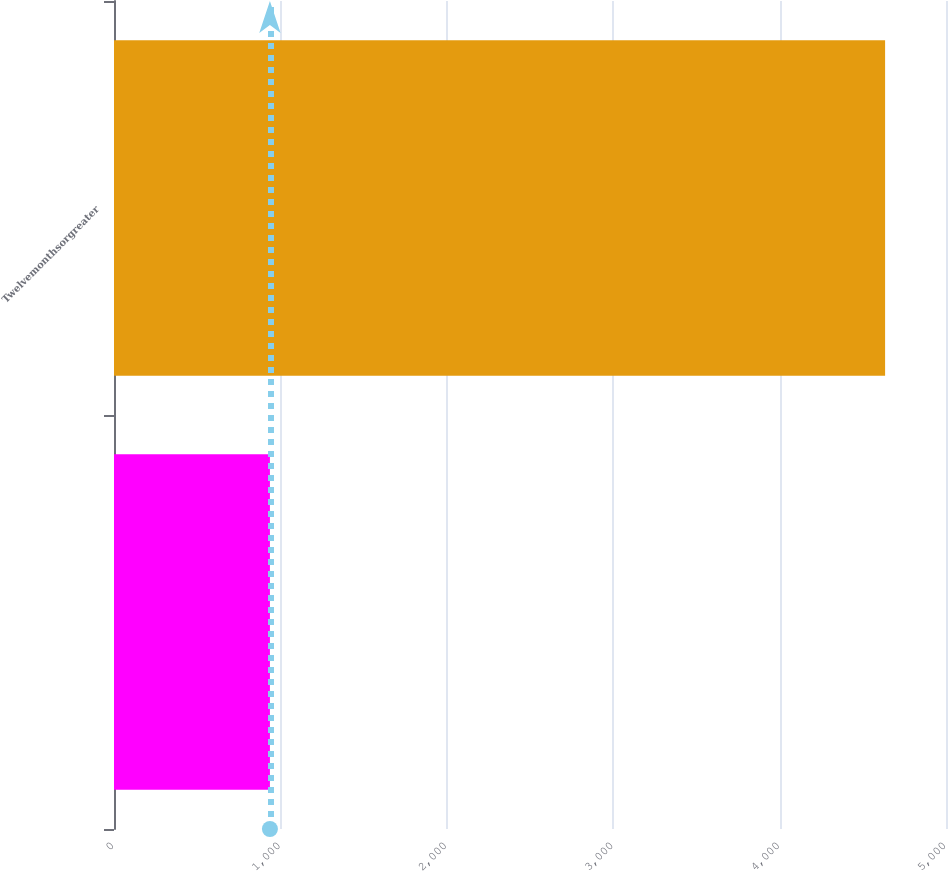Convert chart. <chart><loc_0><loc_0><loc_500><loc_500><bar_chart><ecel><fcel>Twelvemonthsorgreater<nl><fcel>937<fcel>4634<nl></chart> 